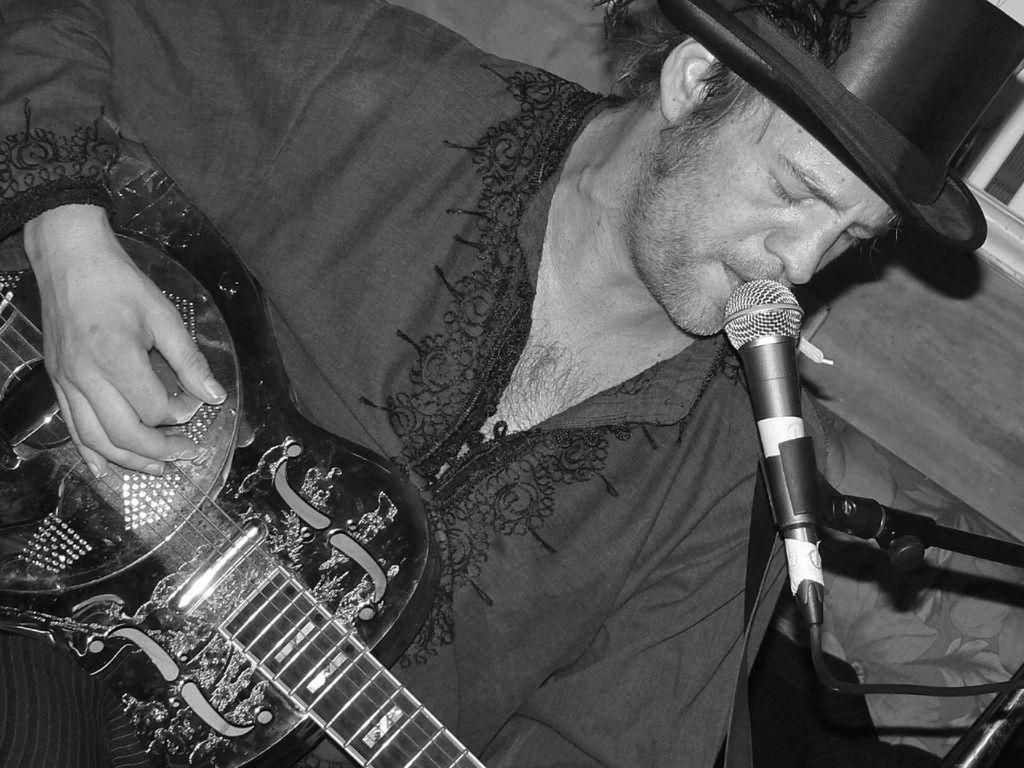In one or two sentences, can you explain what this image depicts? This is a black and white picture. There is a man singing on the mike. He wear a cap and he is playing guitar. 